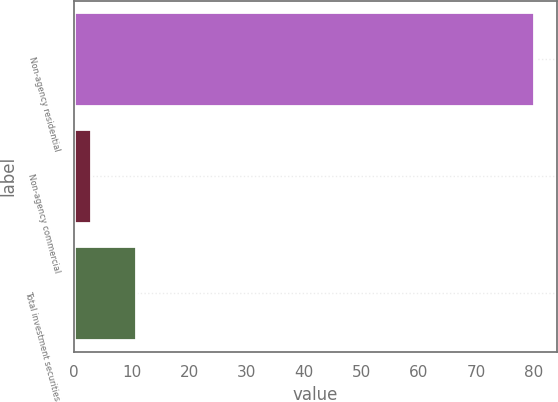<chart> <loc_0><loc_0><loc_500><loc_500><bar_chart><fcel>Non-agency residential<fcel>Non-agency commercial<fcel>Total investment securities<nl><fcel>80<fcel>3<fcel>10.7<nl></chart> 